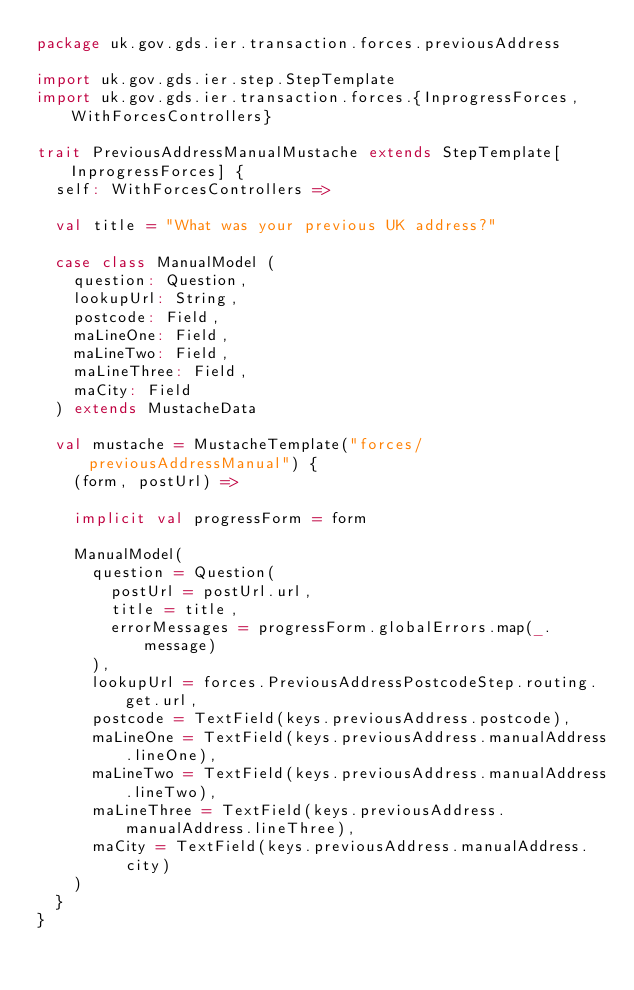<code> <loc_0><loc_0><loc_500><loc_500><_Scala_>package uk.gov.gds.ier.transaction.forces.previousAddress

import uk.gov.gds.ier.step.StepTemplate
import uk.gov.gds.ier.transaction.forces.{InprogressForces, WithForcesControllers}

trait PreviousAddressManualMustache extends StepTemplate[InprogressForces] {
  self: WithForcesControllers =>

  val title = "What was your previous UK address?"

  case class ManualModel (
    question: Question,
    lookupUrl: String,
    postcode: Field,
    maLineOne: Field,
    maLineTwo: Field,
    maLineThree: Field,
    maCity: Field
  ) extends MustacheData

  val mustache = MustacheTemplate("forces/previousAddressManual") {
    (form, postUrl) =>

    implicit val progressForm = form

    ManualModel(
      question = Question(
        postUrl = postUrl.url,
        title = title,
        errorMessages = progressForm.globalErrors.map(_.message)
      ),
      lookupUrl = forces.PreviousAddressPostcodeStep.routing.get.url,
      postcode = TextField(keys.previousAddress.postcode),
      maLineOne = TextField(keys.previousAddress.manualAddress.lineOne),
      maLineTwo = TextField(keys.previousAddress.manualAddress.lineTwo),
      maLineThree = TextField(keys.previousAddress.manualAddress.lineThree),
      maCity = TextField(keys.previousAddress.manualAddress.city)
    )
  }
}

</code> 